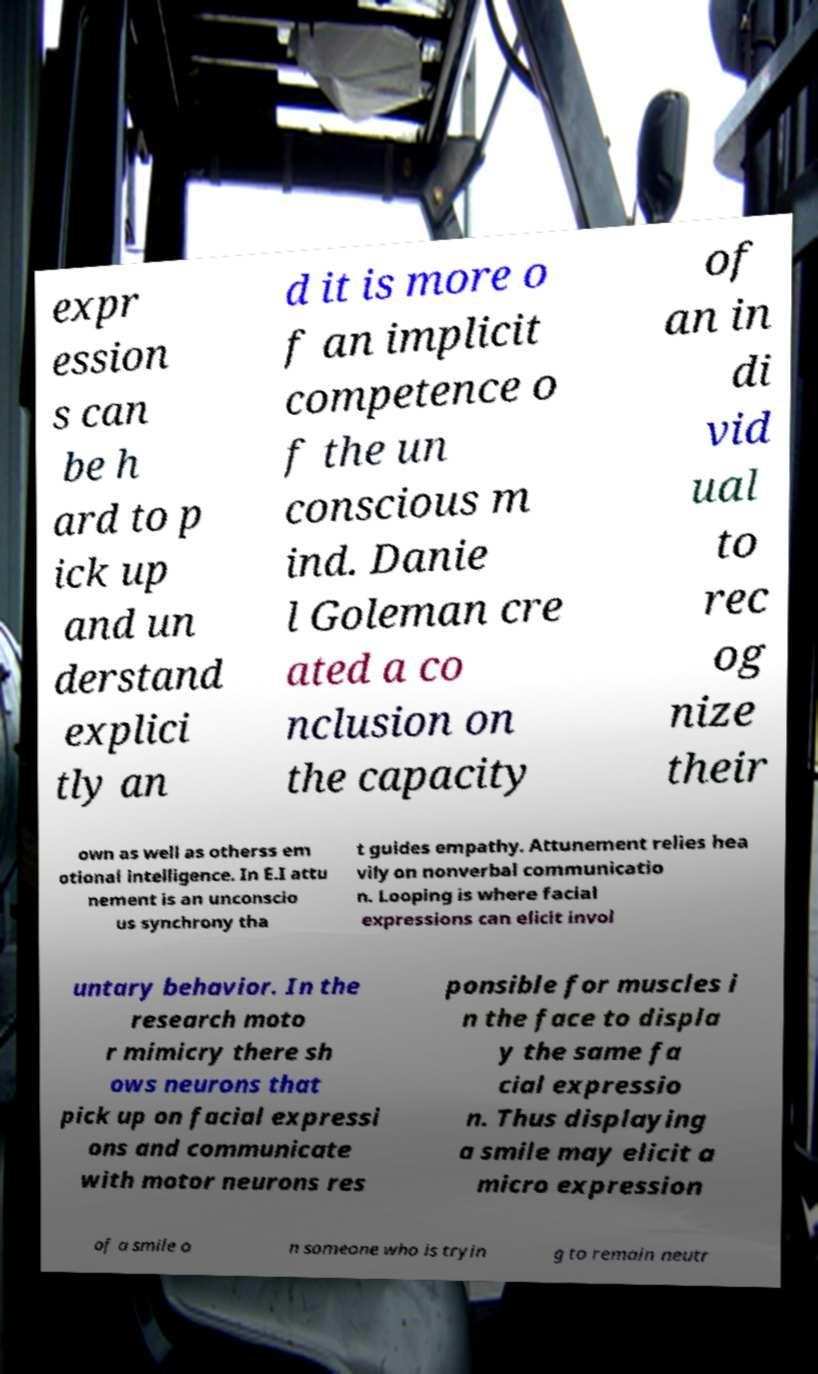Could you extract and type out the text from this image? expr ession s can be h ard to p ick up and un derstand explici tly an d it is more o f an implicit competence o f the un conscious m ind. Danie l Goleman cre ated a co nclusion on the capacity of an in di vid ual to rec og nize their own as well as otherss em otional intelligence. In E.I attu nement is an unconscio us synchrony tha t guides empathy. Attunement relies hea vily on nonverbal communicatio n. Looping is where facial expressions can elicit invol untary behavior. In the research moto r mimicry there sh ows neurons that pick up on facial expressi ons and communicate with motor neurons res ponsible for muscles i n the face to displa y the same fa cial expressio n. Thus displaying a smile may elicit a micro expression of a smile o n someone who is tryin g to remain neutr 